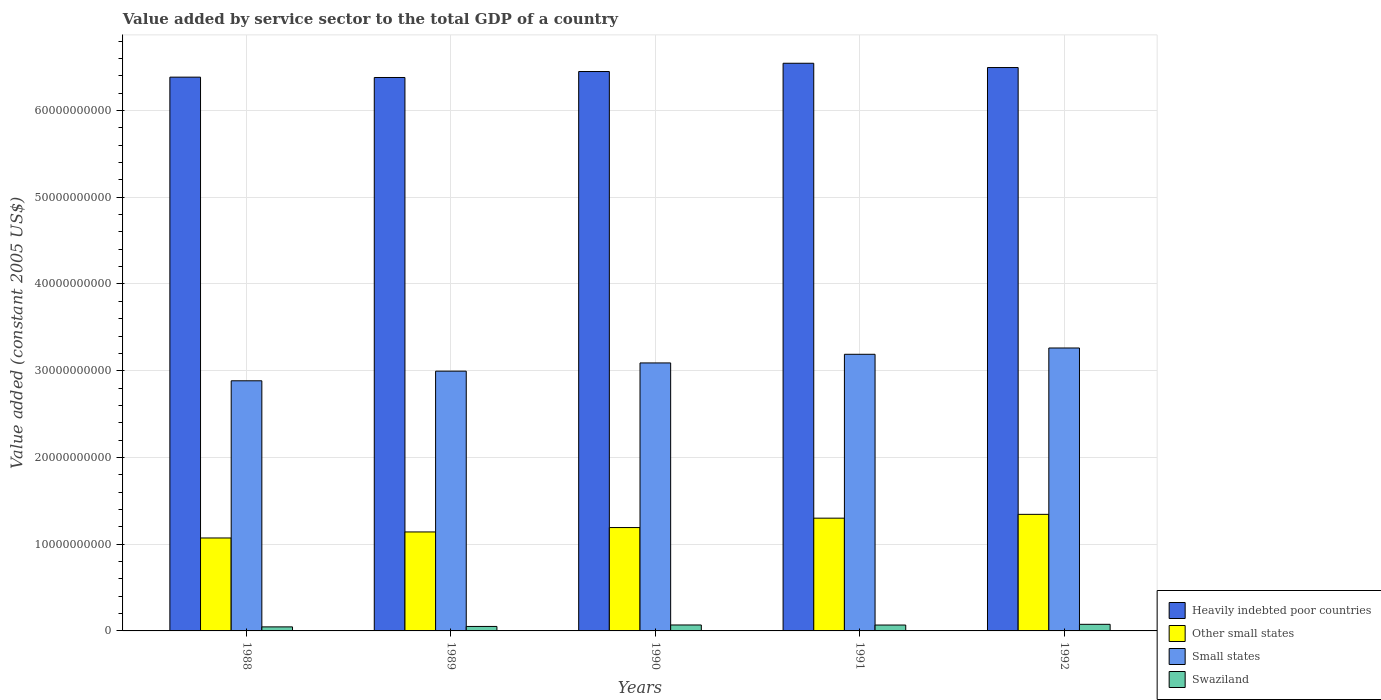How many groups of bars are there?
Give a very brief answer. 5. How many bars are there on the 2nd tick from the right?
Keep it short and to the point. 4. What is the label of the 3rd group of bars from the left?
Your answer should be very brief. 1990. In how many cases, is the number of bars for a given year not equal to the number of legend labels?
Keep it short and to the point. 0. What is the value added by service sector in Heavily indebted poor countries in 1991?
Keep it short and to the point. 6.55e+1. Across all years, what is the maximum value added by service sector in Heavily indebted poor countries?
Provide a short and direct response. 6.55e+1. Across all years, what is the minimum value added by service sector in Swaziland?
Offer a very short reply. 4.66e+08. What is the total value added by service sector in Swaziland in the graph?
Offer a very short reply. 3.11e+09. What is the difference between the value added by service sector in Swaziland in 1990 and that in 1992?
Keep it short and to the point. -7.62e+07. What is the difference between the value added by service sector in Heavily indebted poor countries in 1988 and the value added by service sector in Small states in 1990?
Provide a short and direct response. 3.29e+1. What is the average value added by service sector in Swaziland per year?
Provide a short and direct response. 6.21e+08. In the year 1992, what is the difference between the value added by service sector in Other small states and value added by service sector in Heavily indebted poor countries?
Provide a short and direct response. -5.15e+1. In how many years, is the value added by service sector in Other small states greater than 24000000000 US$?
Ensure brevity in your answer.  0. What is the ratio of the value added by service sector in Other small states in 1988 to that in 1990?
Make the answer very short. 0.9. What is the difference between the highest and the second highest value added by service sector in Other small states?
Ensure brevity in your answer.  4.39e+08. What is the difference between the highest and the lowest value added by service sector in Small states?
Your response must be concise. 3.78e+09. In how many years, is the value added by service sector in Small states greater than the average value added by service sector in Small states taken over all years?
Provide a succinct answer. 3. Is the sum of the value added by service sector in Heavily indebted poor countries in 1988 and 1989 greater than the maximum value added by service sector in Swaziland across all years?
Your answer should be compact. Yes. Is it the case that in every year, the sum of the value added by service sector in Heavily indebted poor countries and value added by service sector in Other small states is greater than the sum of value added by service sector in Small states and value added by service sector in Swaziland?
Ensure brevity in your answer.  No. What does the 2nd bar from the left in 1988 represents?
Your response must be concise. Other small states. What does the 4th bar from the right in 1989 represents?
Offer a terse response. Heavily indebted poor countries. Is it the case that in every year, the sum of the value added by service sector in Other small states and value added by service sector in Swaziland is greater than the value added by service sector in Small states?
Ensure brevity in your answer.  No. How many bars are there?
Your answer should be very brief. 20. Are all the bars in the graph horizontal?
Ensure brevity in your answer.  No. How many years are there in the graph?
Provide a short and direct response. 5. What is the difference between two consecutive major ticks on the Y-axis?
Ensure brevity in your answer.  1.00e+1. Are the values on the major ticks of Y-axis written in scientific E-notation?
Your answer should be compact. No. Does the graph contain any zero values?
Your response must be concise. No. Does the graph contain grids?
Your answer should be compact. Yes. How are the legend labels stacked?
Make the answer very short. Vertical. What is the title of the graph?
Your answer should be very brief. Value added by service sector to the total GDP of a country. What is the label or title of the Y-axis?
Your response must be concise. Value added (constant 2005 US$). What is the Value added (constant 2005 US$) of Heavily indebted poor countries in 1988?
Keep it short and to the point. 6.38e+1. What is the Value added (constant 2005 US$) of Other small states in 1988?
Offer a very short reply. 1.07e+1. What is the Value added (constant 2005 US$) of Small states in 1988?
Your answer should be compact. 2.88e+1. What is the Value added (constant 2005 US$) in Swaziland in 1988?
Provide a succinct answer. 4.66e+08. What is the Value added (constant 2005 US$) of Heavily indebted poor countries in 1989?
Offer a terse response. 6.38e+1. What is the Value added (constant 2005 US$) of Other small states in 1989?
Your response must be concise. 1.14e+1. What is the Value added (constant 2005 US$) of Small states in 1989?
Your response must be concise. 3.00e+1. What is the Value added (constant 2005 US$) of Swaziland in 1989?
Your response must be concise. 5.17e+08. What is the Value added (constant 2005 US$) in Heavily indebted poor countries in 1990?
Make the answer very short. 6.45e+1. What is the Value added (constant 2005 US$) of Other small states in 1990?
Give a very brief answer. 1.19e+1. What is the Value added (constant 2005 US$) of Small states in 1990?
Offer a terse response. 3.09e+1. What is the Value added (constant 2005 US$) in Swaziland in 1990?
Offer a very short reply. 6.85e+08. What is the Value added (constant 2005 US$) in Heavily indebted poor countries in 1991?
Your answer should be compact. 6.55e+1. What is the Value added (constant 2005 US$) of Other small states in 1991?
Provide a short and direct response. 1.30e+1. What is the Value added (constant 2005 US$) in Small states in 1991?
Offer a terse response. 3.19e+1. What is the Value added (constant 2005 US$) in Swaziland in 1991?
Provide a succinct answer. 6.78e+08. What is the Value added (constant 2005 US$) of Heavily indebted poor countries in 1992?
Keep it short and to the point. 6.50e+1. What is the Value added (constant 2005 US$) in Other small states in 1992?
Ensure brevity in your answer.  1.34e+1. What is the Value added (constant 2005 US$) of Small states in 1992?
Ensure brevity in your answer.  3.26e+1. What is the Value added (constant 2005 US$) of Swaziland in 1992?
Offer a very short reply. 7.61e+08. Across all years, what is the maximum Value added (constant 2005 US$) in Heavily indebted poor countries?
Provide a short and direct response. 6.55e+1. Across all years, what is the maximum Value added (constant 2005 US$) in Other small states?
Ensure brevity in your answer.  1.34e+1. Across all years, what is the maximum Value added (constant 2005 US$) of Small states?
Give a very brief answer. 3.26e+1. Across all years, what is the maximum Value added (constant 2005 US$) in Swaziland?
Offer a terse response. 7.61e+08. Across all years, what is the minimum Value added (constant 2005 US$) in Heavily indebted poor countries?
Make the answer very short. 6.38e+1. Across all years, what is the minimum Value added (constant 2005 US$) in Other small states?
Your response must be concise. 1.07e+1. Across all years, what is the minimum Value added (constant 2005 US$) in Small states?
Offer a terse response. 2.88e+1. Across all years, what is the minimum Value added (constant 2005 US$) in Swaziland?
Make the answer very short. 4.66e+08. What is the total Value added (constant 2005 US$) of Heavily indebted poor countries in the graph?
Your response must be concise. 3.23e+11. What is the total Value added (constant 2005 US$) in Other small states in the graph?
Your answer should be compact. 6.05e+1. What is the total Value added (constant 2005 US$) of Small states in the graph?
Ensure brevity in your answer.  1.54e+11. What is the total Value added (constant 2005 US$) of Swaziland in the graph?
Offer a terse response. 3.11e+09. What is the difference between the Value added (constant 2005 US$) of Heavily indebted poor countries in 1988 and that in 1989?
Your answer should be very brief. 3.92e+07. What is the difference between the Value added (constant 2005 US$) in Other small states in 1988 and that in 1989?
Offer a terse response. -6.94e+08. What is the difference between the Value added (constant 2005 US$) in Small states in 1988 and that in 1989?
Your answer should be compact. -1.11e+09. What is the difference between the Value added (constant 2005 US$) of Swaziland in 1988 and that in 1989?
Provide a short and direct response. -5.02e+07. What is the difference between the Value added (constant 2005 US$) of Heavily indebted poor countries in 1988 and that in 1990?
Provide a short and direct response. -6.50e+08. What is the difference between the Value added (constant 2005 US$) of Other small states in 1988 and that in 1990?
Give a very brief answer. -1.20e+09. What is the difference between the Value added (constant 2005 US$) of Small states in 1988 and that in 1990?
Make the answer very short. -2.06e+09. What is the difference between the Value added (constant 2005 US$) of Swaziland in 1988 and that in 1990?
Offer a terse response. -2.19e+08. What is the difference between the Value added (constant 2005 US$) in Heavily indebted poor countries in 1988 and that in 1991?
Provide a succinct answer. -1.60e+09. What is the difference between the Value added (constant 2005 US$) in Other small states in 1988 and that in 1991?
Make the answer very short. -2.28e+09. What is the difference between the Value added (constant 2005 US$) in Small states in 1988 and that in 1991?
Offer a terse response. -3.06e+09. What is the difference between the Value added (constant 2005 US$) in Swaziland in 1988 and that in 1991?
Provide a succinct answer. -2.12e+08. What is the difference between the Value added (constant 2005 US$) in Heavily indebted poor countries in 1988 and that in 1992?
Your response must be concise. -1.11e+09. What is the difference between the Value added (constant 2005 US$) of Other small states in 1988 and that in 1992?
Your response must be concise. -2.72e+09. What is the difference between the Value added (constant 2005 US$) of Small states in 1988 and that in 1992?
Your answer should be very brief. -3.78e+09. What is the difference between the Value added (constant 2005 US$) of Swaziland in 1988 and that in 1992?
Your response must be concise. -2.95e+08. What is the difference between the Value added (constant 2005 US$) in Heavily indebted poor countries in 1989 and that in 1990?
Offer a very short reply. -6.90e+08. What is the difference between the Value added (constant 2005 US$) of Other small states in 1989 and that in 1990?
Your answer should be very brief. -5.06e+08. What is the difference between the Value added (constant 2005 US$) in Small states in 1989 and that in 1990?
Your answer should be very brief. -9.47e+08. What is the difference between the Value added (constant 2005 US$) in Swaziland in 1989 and that in 1990?
Ensure brevity in your answer.  -1.69e+08. What is the difference between the Value added (constant 2005 US$) of Heavily indebted poor countries in 1989 and that in 1991?
Provide a short and direct response. -1.64e+09. What is the difference between the Value added (constant 2005 US$) of Other small states in 1989 and that in 1991?
Make the answer very short. -1.59e+09. What is the difference between the Value added (constant 2005 US$) of Small states in 1989 and that in 1991?
Keep it short and to the point. -1.94e+09. What is the difference between the Value added (constant 2005 US$) of Swaziland in 1989 and that in 1991?
Provide a succinct answer. -1.61e+08. What is the difference between the Value added (constant 2005 US$) in Heavily indebted poor countries in 1989 and that in 1992?
Keep it short and to the point. -1.15e+09. What is the difference between the Value added (constant 2005 US$) of Other small states in 1989 and that in 1992?
Make the answer very short. -2.03e+09. What is the difference between the Value added (constant 2005 US$) in Small states in 1989 and that in 1992?
Provide a short and direct response. -2.67e+09. What is the difference between the Value added (constant 2005 US$) of Swaziland in 1989 and that in 1992?
Provide a succinct answer. -2.45e+08. What is the difference between the Value added (constant 2005 US$) in Heavily indebted poor countries in 1990 and that in 1991?
Offer a very short reply. -9.52e+08. What is the difference between the Value added (constant 2005 US$) in Other small states in 1990 and that in 1991?
Keep it short and to the point. -1.08e+09. What is the difference between the Value added (constant 2005 US$) in Small states in 1990 and that in 1991?
Give a very brief answer. -9.96e+08. What is the difference between the Value added (constant 2005 US$) of Swaziland in 1990 and that in 1991?
Give a very brief answer. 7.23e+06. What is the difference between the Value added (constant 2005 US$) of Heavily indebted poor countries in 1990 and that in 1992?
Provide a short and direct response. -4.59e+08. What is the difference between the Value added (constant 2005 US$) in Other small states in 1990 and that in 1992?
Your answer should be very brief. -1.52e+09. What is the difference between the Value added (constant 2005 US$) of Small states in 1990 and that in 1992?
Your answer should be compact. -1.72e+09. What is the difference between the Value added (constant 2005 US$) in Swaziland in 1990 and that in 1992?
Provide a succinct answer. -7.62e+07. What is the difference between the Value added (constant 2005 US$) of Heavily indebted poor countries in 1991 and that in 1992?
Your answer should be very brief. 4.93e+08. What is the difference between the Value added (constant 2005 US$) of Other small states in 1991 and that in 1992?
Make the answer very short. -4.39e+08. What is the difference between the Value added (constant 2005 US$) in Small states in 1991 and that in 1992?
Provide a short and direct response. -7.27e+08. What is the difference between the Value added (constant 2005 US$) of Swaziland in 1991 and that in 1992?
Give a very brief answer. -8.34e+07. What is the difference between the Value added (constant 2005 US$) of Heavily indebted poor countries in 1988 and the Value added (constant 2005 US$) of Other small states in 1989?
Give a very brief answer. 5.24e+1. What is the difference between the Value added (constant 2005 US$) of Heavily indebted poor countries in 1988 and the Value added (constant 2005 US$) of Small states in 1989?
Your response must be concise. 3.39e+1. What is the difference between the Value added (constant 2005 US$) of Heavily indebted poor countries in 1988 and the Value added (constant 2005 US$) of Swaziland in 1989?
Make the answer very short. 6.33e+1. What is the difference between the Value added (constant 2005 US$) of Other small states in 1988 and the Value added (constant 2005 US$) of Small states in 1989?
Ensure brevity in your answer.  -1.92e+1. What is the difference between the Value added (constant 2005 US$) of Other small states in 1988 and the Value added (constant 2005 US$) of Swaziland in 1989?
Keep it short and to the point. 1.02e+1. What is the difference between the Value added (constant 2005 US$) in Small states in 1988 and the Value added (constant 2005 US$) in Swaziland in 1989?
Your answer should be very brief. 2.83e+1. What is the difference between the Value added (constant 2005 US$) of Heavily indebted poor countries in 1988 and the Value added (constant 2005 US$) of Other small states in 1990?
Provide a short and direct response. 5.19e+1. What is the difference between the Value added (constant 2005 US$) of Heavily indebted poor countries in 1988 and the Value added (constant 2005 US$) of Small states in 1990?
Offer a very short reply. 3.29e+1. What is the difference between the Value added (constant 2005 US$) of Heavily indebted poor countries in 1988 and the Value added (constant 2005 US$) of Swaziland in 1990?
Provide a succinct answer. 6.32e+1. What is the difference between the Value added (constant 2005 US$) in Other small states in 1988 and the Value added (constant 2005 US$) in Small states in 1990?
Offer a terse response. -2.02e+1. What is the difference between the Value added (constant 2005 US$) of Other small states in 1988 and the Value added (constant 2005 US$) of Swaziland in 1990?
Provide a short and direct response. 1.00e+1. What is the difference between the Value added (constant 2005 US$) in Small states in 1988 and the Value added (constant 2005 US$) in Swaziland in 1990?
Ensure brevity in your answer.  2.82e+1. What is the difference between the Value added (constant 2005 US$) in Heavily indebted poor countries in 1988 and the Value added (constant 2005 US$) in Other small states in 1991?
Give a very brief answer. 5.08e+1. What is the difference between the Value added (constant 2005 US$) of Heavily indebted poor countries in 1988 and the Value added (constant 2005 US$) of Small states in 1991?
Give a very brief answer. 3.20e+1. What is the difference between the Value added (constant 2005 US$) in Heavily indebted poor countries in 1988 and the Value added (constant 2005 US$) in Swaziland in 1991?
Offer a terse response. 6.32e+1. What is the difference between the Value added (constant 2005 US$) of Other small states in 1988 and the Value added (constant 2005 US$) of Small states in 1991?
Give a very brief answer. -2.12e+1. What is the difference between the Value added (constant 2005 US$) in Other small states in 1988 and the Value added (constant 2005 US$) in Swaziland in 1991?
Make the answer very short. 1.00e+1. What is the difference between the Value added (constant 2005 US$) in Small states in 1988 and the Value added (constant 2005 US$) in Swaziland in 1991?
Provide a short and direct response. 2.82e+1. What is the difference between the Value added (constant 2005 US$) in Heavily indebted poor countries in 1988 and the Value added (constant 2005 US$) in Other small states in 1992?
Your answer should be compact. 5.04e+1. What is the difference between the Value added (constant 2005 US$) in Heavily indebted poor countries in 1988 and the Value added (constant 2005 US$) in Small states in 1992?
Offer a very short reply. 3.12e+1. What is the difference between the Value added (constant 2005 US$) in Heavily indebted poor countries in 1988 and the Value added (constant 2005 US$) in Swaziland in 1992?
Keep it short and to the point. 6.31e+1. What is the difference between the Value added (constant 2005 US$) in Other small states in 1988 and the Value added (constant 2005 US$) in Small states in 1992?
Your answer should be very brief. -2.19e+1. What is the difference between the Value added (constant 2005 US$) in Other small states in 1988 and the Value added (constant 2005 US$) in Swaziland in 1992?
Ensure brevity in your answer.  9.96e+09. What is the difference between the Value added (constant 2005 US$) of Small states in 1988 and the Value added (constant 2005 US$) of Swaziland in 1992?
Keep it short and to the point. 2.81e+1. What is the difference between the Value added (constant 2005 US$) of Heavily indebted poor countries in 1989 and the Value added (constant 2005 US$) of Other small states in 1990?
Offer a terse response. 5.19e+1. What is the difference between the Value added (constant 2005 US$) of Heavily indebted poor countries in 1989 and the Value added (constant 2005 US$) of Small states in 1990?
Provide a succinct answer. 3.29e+1. What is the difference between the Value added (constant 2005 US$) of Heavily indebted poor countries in 1989 and the Value added (constant 2005 US$) of Swaziland in 1990?
Your answer should be compact. 6.31e+1. What is the difference between the Value added (constant 2005 US$) of Other small states in 1989 and the Value added (constant 2005 US$) of Small states in 1990?
Ensure brevity in your answer.  -1.95e+1. What is the difference between the Value added (constant 2005 US$) in Other small states in 1989 and the Value added (constant 2005 US$) in Swaziland in 1990?
Offer a terse response. 1.07e+1. What is the difference between the Value added (constant 2005 US$) in Small states in 1989 and the Value added (constant 2005 US$) in Swaziland in 1990?
Your answer should be compact. 2.93e+1. What is the difference between the Value added (constant 2005 US$) in Heavily indebted poor countries in 1989 and the Value added (constant 2005 US$) in Other small states in 1991?
Your answer should be very brief. 5.08e+1. What is the difference between the Value added (constant 2005 US$) of Heavily indebted poor countries in 1989 and the Value added (constant 2005 US$) of Small states in 1991?
Your answer should be compact. 3.19e+1. What is the difference between the Value added (constant 2005 US$) in Heavily indebted poor countries in 1989 and the Value added (constant 2005 US$) in Swaziland in 1991?
Make the answer very short. 6.31e+1. What is the difference between the Value added (constant 2005 US$) of Other small states in 1989 and the Value added (constant 2005 US$) of Small states in 1991?
Make the answer very short. -2.05e+1. What is the difference between the Value added (constant 2005 US$) in Other small states in 1989 and the Value added (constant 2005 US$) in Swaziland in 1991?
Provide a succinct answer. 1.07e+1. What is the difference between the Value added (constant 2005 US$) of Small states in 1989 and the Value added (constant 2005 US$) of Swaziland in 1991?
Make the answer very short. 2.93e+1. What is the difference between the Value added (constant 2005 US$) of Heavily indebted poor countries in 1989 and the Value added (constant 2005 US$) of Other small states in 1992?
Provide a short and direct response. 5.04e+1. What is the difference between the Value added (constant 2005 US$) of Heavily indebted poor countries in 1989 and the Value added (constant 2005 US$) of Small states in 1992?
Offer a terse response. 3.12e+1. What is the difference between the Value added (constant 2005 US$) of Heavily indebted poor countries in 1989 and the Value added (constant 2005 US$) of Swaziland in 1992?
Keep it short and to the point. 6.30e+1. What is the difference between the Value added (constant 2005 US$) of Other small states in 1989 and the Value added (constant 2005 US$) of Small states in 1992?
Offer a terse response. -2.12e+1. What is the difference between the Value added (constant 2005 US$) of Other small states in 1989 and the Value added (constant 2005 US$) of Swaziland in 1992?
Provide a short and direct response. 1.07e+1. What is the difference between the Value added (constant 2005 US$) of Small states in 1989 and the Value added (constant 2005 US$) of Swaziland in 1992?
Your answer should be very brief. 2.92e+1. What is the difference between the Value added (constant 2005 US$) of Heavily indebted poor countries in 1990 and the Value added (constant 2005 US$) of Other small states in 1991?
Provide a succinct answer. 5.15e+1. What is the difference between the Value added (constant 2005 US$) of Heavily indebted poor countries in 1990 and the Value added (constant 2005 US$) of Small states in 1991?
Provide a short and direct response. 3.26e+1. What is the difference between the Value added (constant 2005 US$) of Heavily indebted poor countries in 1990 and the Value added (constant 2005 US$) of Swaziland in 1991?
Provide a succinct answer. 6.38e+1. What is the difference between the Value added (constant 2005 US$) of Other small states in 1990 and the Value added (constant 2005 US$) of Small states in 1991?
Provide a short and direct response. -2.00e+1. What is the difference between the Value added (constant 2005 US$) in Other small states in 1990 and the Value added (constant 2005 US$) in Swaziland in 1991?
Offer a very short reply. 1.12e+1. What is the difference between the Value added (constant 2005 US$) of Small states in 1990 and the Value added (constant 2005 US$) of Swaziland in 1991?
Offer a terse response. 3.02e+1. What is the difference between the Value added (constant 2005 US$) of Heavily indebted poor countries in 1990 and the Value added (constant 2005 US$) of Other small states in 1992?
Your answer should be very brief. 5.11e+1. What is the difference between the Value added (constant 2005 US$) of Heavily indebted poor countries in 1990 and the Value added (constant 2005 US$) of Small states in 1992?
Provide a succinct answer. 3.19e+1. What is the difference between the Value added (constant 2005 US$) in Heavily indebted poor countries in 1990 and the Value added (constant 2005 US$) in Swaziland in 1992?
Your answer should be compact. 6.37e+1. What is the difference between the Value added (constant 2005 US$) of Other small states in 1990 and the Value added (constant 2005 US$) of Small states in 1992?
Your response must be concise. -2.07e+1. What is the difference between the Value added (constant 2005 US$) of Other small states in 1990 and the Value added (constant 2005 US$) of Swaziland in 1992?
Keep it short and to the point. 1.12e+1. What is the difference between the Value added (constant 2005 US$) of Small states in 1990 and the Value added (constant 2005 US$) of Swaziland in 1992?
Provide a succinct answer. 3.01e+1. What is the difference between the Value added (constant 2005 US$) in Heavily indebted poor countries in 1991 and the Value added (constant 2005 US$) in Other small states in 1992?
Make the answer very short. 5.20e+1. What is the difference between the Value added (constant 2005 US$) of Heavily indebted poor countries in 1991 and the Value added (constant 2005 US$) of Small states in 1992?
Provide a succinct answer. 3.28e+1. What is the difference between the Value added (constant 2005 US$) of Heavily indebted poor countries in 1991 and the Value added (constant 2005 US$) of Swaziland in 1992?
Give a very brief answer. 6.47e+1. What is the difference between the Value added (constant 2005 US$) in Other small states in 1991 and the Value added (constant 2005 US$) in Small states in 1992?
Your response must be concise. -1.96e+1. What is the difference between the Value added (constant 2005 US$) of Other small states in 1991 and the Value added (constant 2005 US$) of Swaziland in 1992?
Offer a very short reply. 1.22e+1. What is the difference between the Value added (constant 2005 US$) of Small states in 1991 and the Value added (constant 2005 US$) of Swaziland in 1992?
Make the answer very short. 3.11e+1. What is the average Value added (constant 2005 US$) in Heavily indebted poor countries per year?
Offer a terse response. 6.45e+1. What is the average Value added (constant 2005 US$) of Other small states per year?
Provide a short and direct response. 1.21e+1. What is the average Value added (constant 2005 US$) of Small states per year?
Offer a terse response. 3.08e+1. What is the average Value added (constant 2005 US$) of Swaziland per year?
Your answer should be very brief. 6.21e+08. In the year 1988, what is the difference between the Value added (constant 2005 US$) of Heavily indebted poor countries and Value added (constant 2005 US$) of Other small states?
Make the answer very short. 5.31e+1. In the year 1988, what is the difference between the Value added (constant 2005 US$) in Heavily indebted poor countries and Value added (constant 2005 US$) in Small states?
Give a very brief answer. 3.50e+1. In the year 1988, what is the difference between the Value added (constant 2005 US$) of Heavily indebted poor countries and Value added (constant 2005 US$) of Swaziland?
Give a very brief answer. 6.34e+1. In the year 1988, what is the difference between the Value added (constant 2005 US$) of Other small states and Value added (constant 2005 US$) of Small states?
Your answer should be very brief. -1.81e+1. In the year 1988, what is the difference between the Value added (constant 2005 US$) of Other small states and Value added (constant 2005 US$) of Swaziland?
Make the answer very short. 1.03e+1. In the year 1988, what is the difference between the Value added (constant 2005 US$) in Small states and Value added (constant 2005 US$) in Swaziland?
Give a very brief answer. 2.84e+1. In the year 1989, what is the difference between the Value added (constant 2005 US$) in Heavily indebted poor countries and Value added (constant 2005 US$) in Other small states?
Make the answer very short. 5.24e+1. In the year 1989, what is the difference between the Value added (constant 2005 US$) of Heavily indebted poor countries and Value added (constant 2005 US$) of Small states?
Keep it short and to the point. 3.39e+1. In the year 1989, what is the difference between the Value added (constant 2005 US$) in Heavily indebted poor countries and Value added (constant 2005 US$) in Swaziland?
Offer a terse response. 6.33e+1. In the year 1989, what is the difference between the Value added (constant 2005 US$) of Other small states and Value added (constant 2005 US$) of Small states?
Your response must be concise. -1.85e+1. In the year 1989, what is the difference between the Value added (constant 2005 US$) in Other small states and Value added (constant 2005 US$) in Swaziland?
Provide a short and direct response. 1.09e+1. In the year 1989, what is the difference between the Value added (constant 2005 US$) of Small states and Value added (constant 2005 US$) of Swaziland?
Give a very brief answer. 2.94e+1. In the year 1990, what is the difference between the Value added (constant 2005 US$) of Heavily indebted poor countries and Value added (constant 2005 US$) of Other small states?
Offer a terse response. 5.26e+1. In the year 1990, what is the difference between the Value added (constant 2005 US$) of Heavily indebted poor countries and Value added (constant 2005 US$) of Small states?
Your answer should be compact. 3.36e+1. In the year 1990, what is the difference between the Value added (constant 2005 US$) of Heavily indebted poor countries and Value added (constant 2005 US$) of Swaziland?
Your answer should be compact. 6.38e+1. In the year 1990, what is the difference between the Value added (constant 2005 US$) in Other small states and Value added (constant 2005 US$) in Small states?
Your answer should be very brief. -1.90e+1. In the year 1990, what is the difference between the Value added (constant 2005 US$) in Other small states and Value added (constant 2005 US$) in Swaziland?
Provide a short and direct response. 1.12e+1. In the year 1990, what is the difference between the Value added (constant 2005 US$) in Small states and Value added (constant 2005 US$) in Swaziland?
Your answer should be compact. 3.02e+1. In the year 1991, what is the difference between the Value added (constant 2005 US$) in Heavily indebted poor countries and Value added (constant 2005 US$) in Other small states?
Offer a terse response. 5.24e+1. In the year 1991, what is the difference between the Value added (constant 2005 US$) in Heavily indebted poor countries and Value added (constant 2005 US$) in Small states?
Your answer should be compact. 3.36e+1. In the year 1991, what is the difference between the Value added (constant 2005 US$) in Heavily indebted poor countries and Value added (constant 2005 US$) in Swaziland?
Make the answer very short. 6.48e+1. In the year 1991, what is the difference between the Value added (constant 2005 US$) of Other small states and Value added (constant 2005 US$) of Small states?
Offer a very short reply. -1.89e+1. In the year 1991, what is the difference between the Value added (constant 2005 US$) of Other small states and Value added (constant 2005 US$) of Swaziland?
Offer a terse response. 1.23e+1. In the year 1991, what is the difference between the Value added (constant 2005 US$) in Small states and Value added (constant 2005 US$) in Swaziland?
Provide a succinct answer. 3.12e+1. In the year 1992, what is the difference between the Value added (constant 2005 US$) of Heavily indebted poor countries and Value added (constant 2005 US$) of Other small states?
Your answer should be compact. 5.15e+1. In the year 1992, what is the difference between the Value added (constant 2005 US$) of Heavily indebted poor countries and Value added (constant 2005 US$) of Small states?
Your response must be concise. 3.23e+1. In the year 1992, what is the difference between the Value added (constant 2005 US$) in Heavily indebted poor countries and Value added (constant 2005 US$) in Swaziland?
Offer a very short reply. 6.42e+1. In the year 1992, what is the difference between the Value added (constant 2005 US$) in Other small states and Value added (constant 2005 US$) in Small states?
Your answer should be compact. -1.92e+1. In the year 1992, what is the difference between the Value added (constant 2005 US$) in Other small states and Value added (constant 2005 US$) in Swaziland?
Provide a succinct answer. 1.27e+1. In the year 1992, what is the difference between the Value added (constant 2005 US$) of Small states and Value added (constant 2005 US$) of Swaziland?
Offer a terse response. 3.19e+1. What is the ratio of the Value added (constant 2005 US$) in Heavily indebted poor countries in 1988 to that in 1989?
Offer a very short reply. 1. What is the ratio of the Value added (constant 2005 US$) of Other small states in 1988 to that in 1989?
Offer a terse response. 0.94. What is the ratio of the Value added (constant 2005 US$) of Small states in 1988 to that in 1989?
Offer a very short reply. 0.96. What is the ratio of the Value added (constant 2005 US$) of Swaziland in 1988 to that in 1989?
Your response must be concise. 0.9. What is the ratio of the Value added (constant 2005 US$) of Heavily indebted poor countries in 1988 to that in 1990?
Keep it short and to the point. 0.99. What is the ratio of the Value added (constant 2005 US$) in Other small states in 1988 to that in 1990?
Keep it short and to the point. 0.9. What is the ratio of the Value added (constant 2005 US$) of Small states in 1988 to that in 1990?
Keep it short and to the point. 0.93. What is the ratio of the Value added (constant 2005 US$) of Swaziland in 1988 to that in 1990?
Make the answer very short. 0.68. What is the ratio of the Value added (constant 2005 US$) of Heavily indebted poor countries in 1988 to that in 1991?
Offer a terse response. 0.98. What is the ratio of the Value added (constant 2005 US$) of Other small states in 1988 to that in 1991?
Provide a succinct answer. 0.82. What is the ratio of the Value added (constant 2005 US$) of Small states in 1988 to that in 1991?
Keep it short and to the point. 0.9. What is the ratio of the Value added (constant 2005 US$) of Swaziland in 1988 to that in 1991?
Give a very brief answer. 0.69. What is the ratio of the Value added (constant 2005 US$) of Heavily indebted poor countries in 1988 to that in 1992?
Make the answer very short. 0.98. What is the ratio of the Value added (constant 2005 US$) in Other small states in 1988 to that in 1992?
Offer a terse response. 0.8. What is the ratio of the Value added (constant 2005 US$) in Small states in 1988 to that in 1992?
Your answer should be very brief. 0.88. What is the ratio of the Value added (constant 2005 US$) in Swaziland in 1988 to that in 1992?
Keep it short and to the point. 0.61. What is the ratio of the Value added (constant 2005 US$) of Heavily indebted poor countries in 1989 to that in 1990?
Offer a very short reply. 0.99. What is the ratio of the Value added (constant 2005 US$) in Other small states in 1989 to that in 1990?
Offer a terse response. 0.96. What is the ratio of the Value added (constant 2005 US$) of Small states in 1989 to that in 1990?
Make the answer very short. 0.97. What is the ratio of the Value added (constant 2005 US$) of Swaziland in 1989 to that in 1990?
Offer a very short reply. 0.75. What is the ratio of the Value added (constant 2005 US$) in Heavily indebted poor countries in 1989 to that in 1991?
Your answer should be compact. 0.97. What is the ratio of the Value added (constant 2005 US$) in Other small states in 1989 to that in 1991?
Give a very brief answer. 0.88. What is the ratio of the Value added (constant 2005 US$) of Small states in 1989 to that in 1991?
Provide a short and direct response. 0.94. What is the ratio of the Value added (constant 2005 US$) in Swaziland in 1989 to that in 1991?
Make the answer very short. 0.76. What is the ratio of the Value added (constant 2005 US$) in Heavily indebted poor countries in 1989 to that in 1992?
Provide a short and direct response. 0.98. What is the ratio of the Value added (constant 2005 US$) of Other small states in 1989 to that in 1992?
Ensure brevity in your answer.  0.85. What is the ratio of the Value added (constant 2005 US$) in Small states in 1989 to that in 1992?
Keep it short and to the point. 0.92. What is the ratio of the Value added (constant 2005 US$) in Swaziland in 1989 to that in 1992?
Provide a succinct answer. 0.68. What is the ratio of the Value added (constant 2005 US$) in Heavily indebted poor countries in 1990 to that in 1991?
Ensure brevity in your answer.  0.99. What is the ratio of the Value added (constant 2005 US$) in Other small states in 1990 to that in 1991?
Provide a short and direct response. 0.92. What is the ratio of the Value added (constant 2005 US$) of Small states in 1990 to that in 1991?
Offer a terse response. 0.97. What is the ratio of the Value added (constant 2005 US$) of Swaziland in 1990 to that in 1991?
Offer a terse response. 1.01. What is the ratio of the Value added (constant 2005 US$) in Other small states in 1990 to that in 1992?
Provide a short and direct response. 0.89. What is the ratio of the Value added (constant 2005 US$) in Small states in 1990 to that in 1992?
Your response must be concise. 0.95. What is the ratio of the Value added (constant 2005 US$) in Heavily indebted poor countries in 1991 to that in 1992?
Provide a succinct answer. 1.01. What is the ratio of the Value added (constant 2005 US$) of Other small states in 1991 to that in 1992?
Keep it short and to the point. 0.97. What is the ratio of the Value added (constant 2005 US$) in Small states in 1991 to that in 1992?
Give a very brief answer. 0.98. What is the ratio of the Value added (constant 2005 US$) in Swaziland in 1991 to that in 1992?
Give a very brief answer. 0.89. What is the difference between the highest and the second highest Value added (constant 2005 US$) of Heavily indebted poor countries?
Make the answer very short. 4.93e+08. What is the difference between the highest and the second highest Value added (constant 2005 US$) of Other small states?
Ensure brevity in your answer.  4.39e+08. What is the difference between the highest and the second highest Value added (constant 2005 US$) of Small states?
Keep it short and to the point. 7.27e+08. What is the difference between the highest and the second highest Value added (constant 2005 US$) of Swaziland?
Your answer should be compact. 7.62e+07. What is the difference between the highest and the lowest Value added (constant 2005 US$) of Heavily indebted poor countries?
Ensure brevity in your answer.  1.64e+09. What is the difference between the highest and the lowest Value added (constant 2005 US$) in Other small states?
Ensure brevity in your answer.  2.72e+09. What is the difference between the highest and the lowest Value added (constant 2005 US$) in Small states?
Make the answer very short. 3.78e+09. What is the difference between the highest and the lowest Value added (constant 2005 US$) of Swaziland?
Offer a terse response. 2.95e+08. 